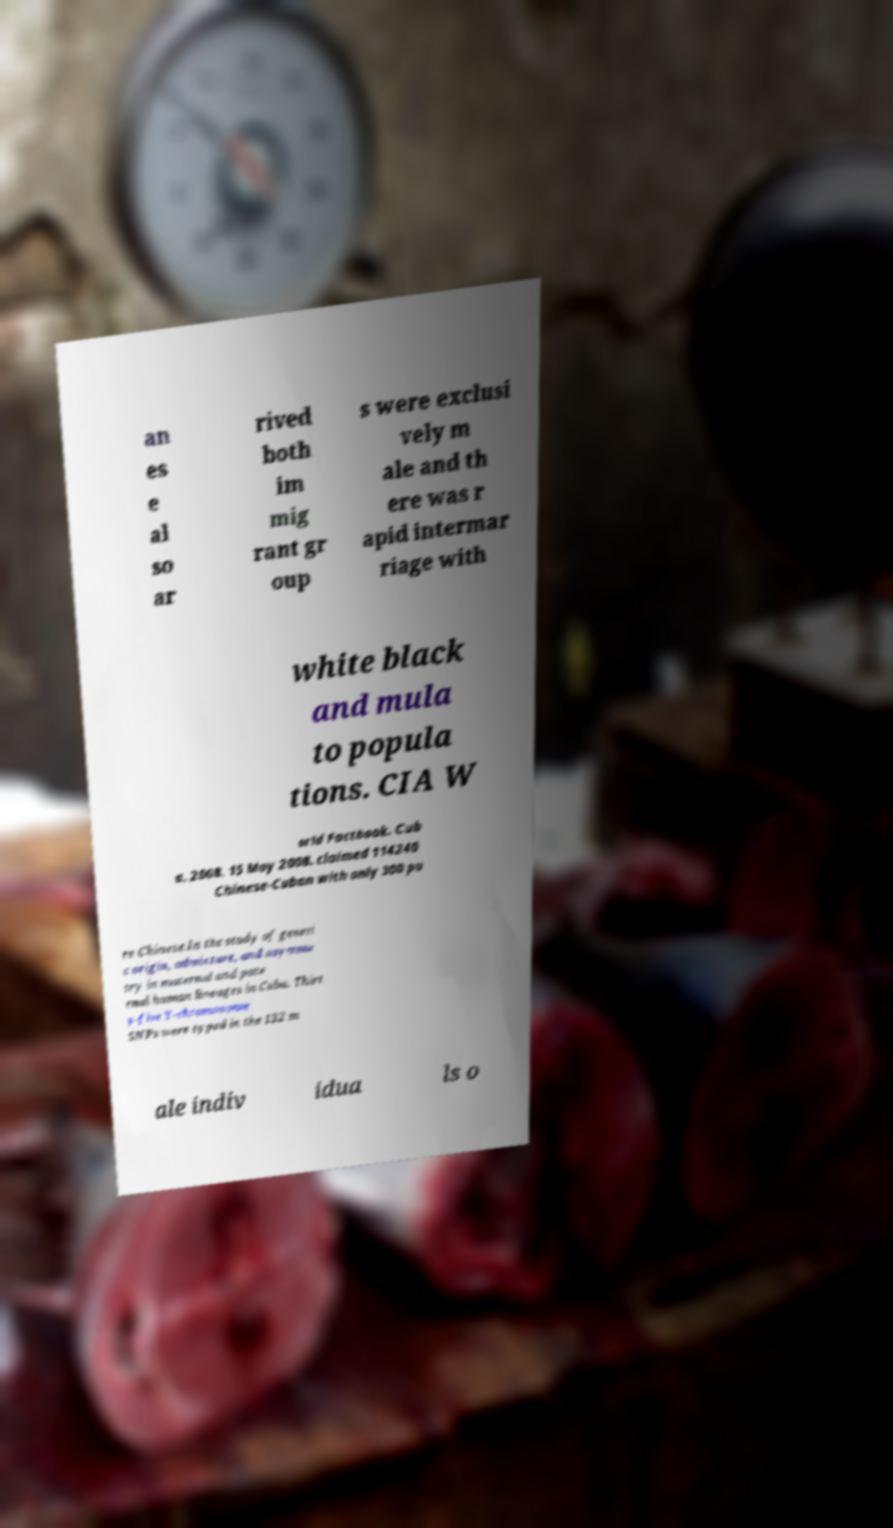Could you extract and type out the text from this image? an es e al so ar rived both im mig rant gr oup s were exclusi vely m ale and th ere was r apid intermar riage with white black and mula to popula tions. CIA W orld Factbook. Cub a. 2008. 15 May 2008. claimed 114240 Chinese-Cuban with only 300 pu re Chinese.In the study of geneti c origin, admixture, and asymme try in maternal and pate rnal human lineages in Cuba. Thirt y-five Y-chromosome SNPs were typed in the 132 m ale indiv idua ls o 